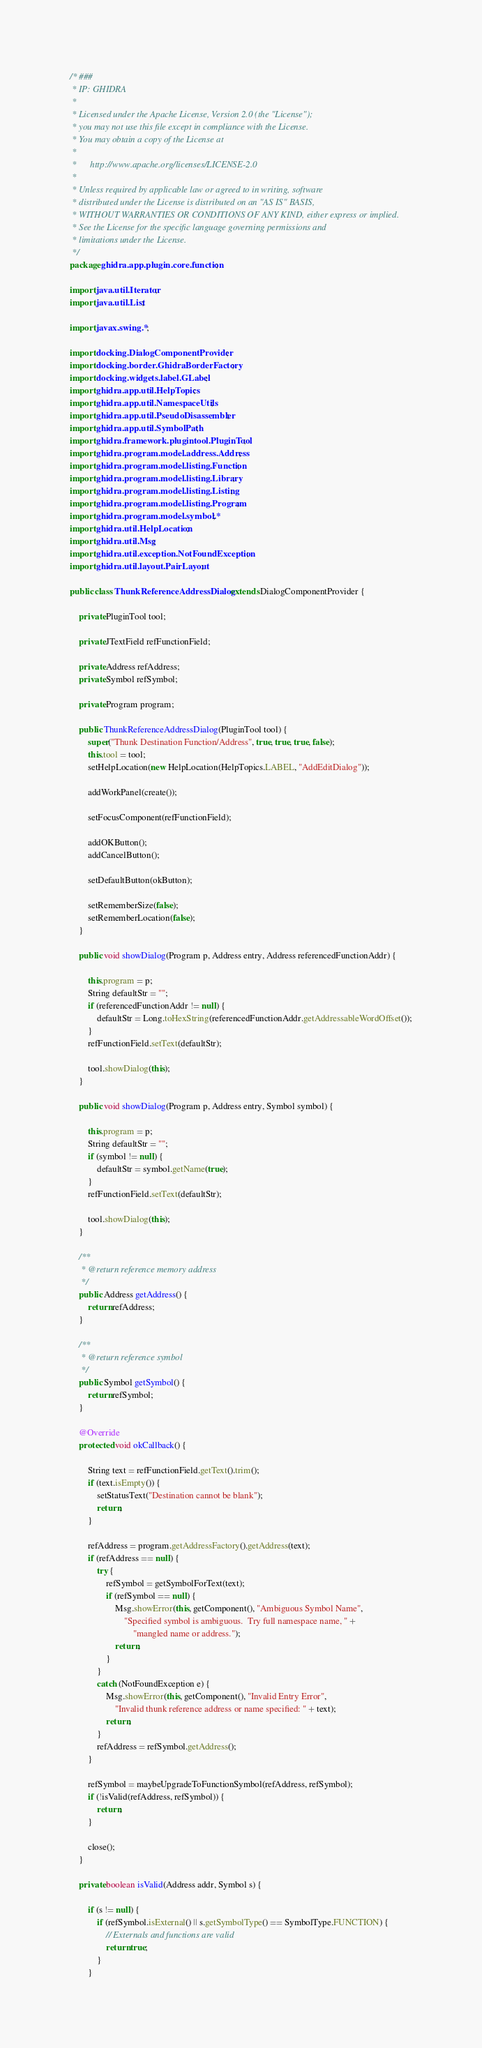Convert code to text. <code><loc_0><loc_0><loc_500><loc_500><_Java_>/* ###
 * IP: GHIDRA
 *
 * Licensed under the Apache License, Version 2.0 (the "License");
 * you may not use this file except in compliance with the License.
 * You may obtain a copy of the License at
 * 
 *      http://www.apache.org/licenses/LICENSE-2.0
 * 
 * Unless required by applicable law or agreed to in writing, software
 * distributed under the License is distributed on an "AS IS" BASIS,
 * WITHOUT WARRANTIES OR CONDITIONS OF ANY KIND, either express or implied.
 * See the License for the specific language governing permissions and
 * limitations under the License.
 */
package ghidra.app.plugin.core.function;

import java.util.Iterator;
import java.util.List;

import javax.swing.*;

import docking.DialogComponentProvider;
import docking.border.GhidraBorderFactory;
import docking.widgets.label.GLabel;
import ghidra.app.util.HelpTopics;
import ghidra.app.util.NamespaceUtils;
import ghidra.app.util.PseudoDisassembler;
import ghidra.app.util.SymbolPath;
import ghidra.framework.plugintool.PluginTool;
import ghidra.program.model.address.Address;
import ghidra.program.model.listing.Function;
import ghidra.program.model.listing.Library;
import ghidra.program.model.listing.Listing;
import ghidra.program.model.listing.Program;
import ghidra.program.model.symbol.*;
import ghidra.util.HelpLocation;
import ghidra.util.Msg;
import ghidra.util.exception.NotFoundException;
import ghidra.util.layout.PairLayout;

public class ThunkReferenceAddressDialog extends DialogComponentProvider {

	private PluginTool tool;

	private JTextField refFunctionField;

	private Address refAddress;
	private Symbol refSymbol;

	private Program program;

	public ThunkReferenceAddressDialog(PluginTool tool) {
		super("Thunk Destination Function/Address", true, true, true, false);
		this.tool = tool;
		setHelpLocation(new HelpLocation(HelpTopics.LABEL, "AddEditDialog"));

		addWorkPanel(create());

		setFocusComponent(refFunctionField);

		addOKButton();
		addCancelButton();

		setDefaultButton(okButton);

		setRememberSize(false);
		setRememberLocation(false);
	}

	public void showDialog(Program p, Address entry, Address referencedFunctionAddr) {

		this.program = p;
		String defaultStr = "";
		if (referencedFunctionAddr != null) {
			defaultStr = Long.toHexString(referencedFunctionAddr.getAddressableWordOffset());
		}
		refFunctionField.setText(defaultStr);

		tool.showDialog(this);
	}

	public void showDialog(Program p, Address entry, Symbol symbol) {

		this.program = p;
		String defaultStr = "";
		if (symbol != null) {
			defaultStr = symbol.getName(true);
		}
		refFunctionField.setText(defaultStr);

		tool.showDialog(this);
	}

	/**
	 * @return reference memory address
	 */
	public Address getAddress() {
		return refAddress;
	}

	/**
	 * @return reference symbol
	 */
	public Symbol getSymbol() {
		return refSymbol;
	}

	@Override
	protected void okCallback() {

		String text = refFunctionField.getText().trim();
		if (text.isEmpty()) {
			setStatusText("Destination cannot be blank");
			return;
		}

		refAddress = program.getAddressFactory().getAddress(text);
		if (refAddress == null) {
			try {
				refSymbol = getSymbolForText(text);
				if (refSymbol == null) {
					Msg.showError(this, getComponent(), "Ambiguous Symbol Name",
						"Specified symbol is ambiguous.  Try full namespace name, " +
							"mangled name or address.");
					return;
				}
			}
			catch (NotFoundException e) {
				Msg.showError(this, getComponent(), "Invalid Entry Error",
					"Invalid thunk reference address or name specified: " + text);
				return;
			}
			refAddress = refSymbol.getAddress();
		}

		refSymbol = maybeUpgradeToFunctionSymbol(refAddress, refSymbol);
		if (!isValid(refAddress, refSymbol)) {
			return;
		}

		close();
	}

	private boolean isValid(Address addr, Symbol s) {

		if (s != null) {
			if (refSymbol.isExternal() || s.getSymbolType() == SymbolType.FUNCTION) {
				// Externals and functions are valid
				return true;
			}
		}
</code> 